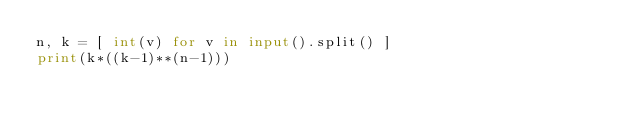Convert code to text. <code><loc_0><loc_0><loc_500><loc_500><_Python_>n, k = [ int(v) for v in input().split() ]
print(k*((k-1)**(n-1)))</code> 